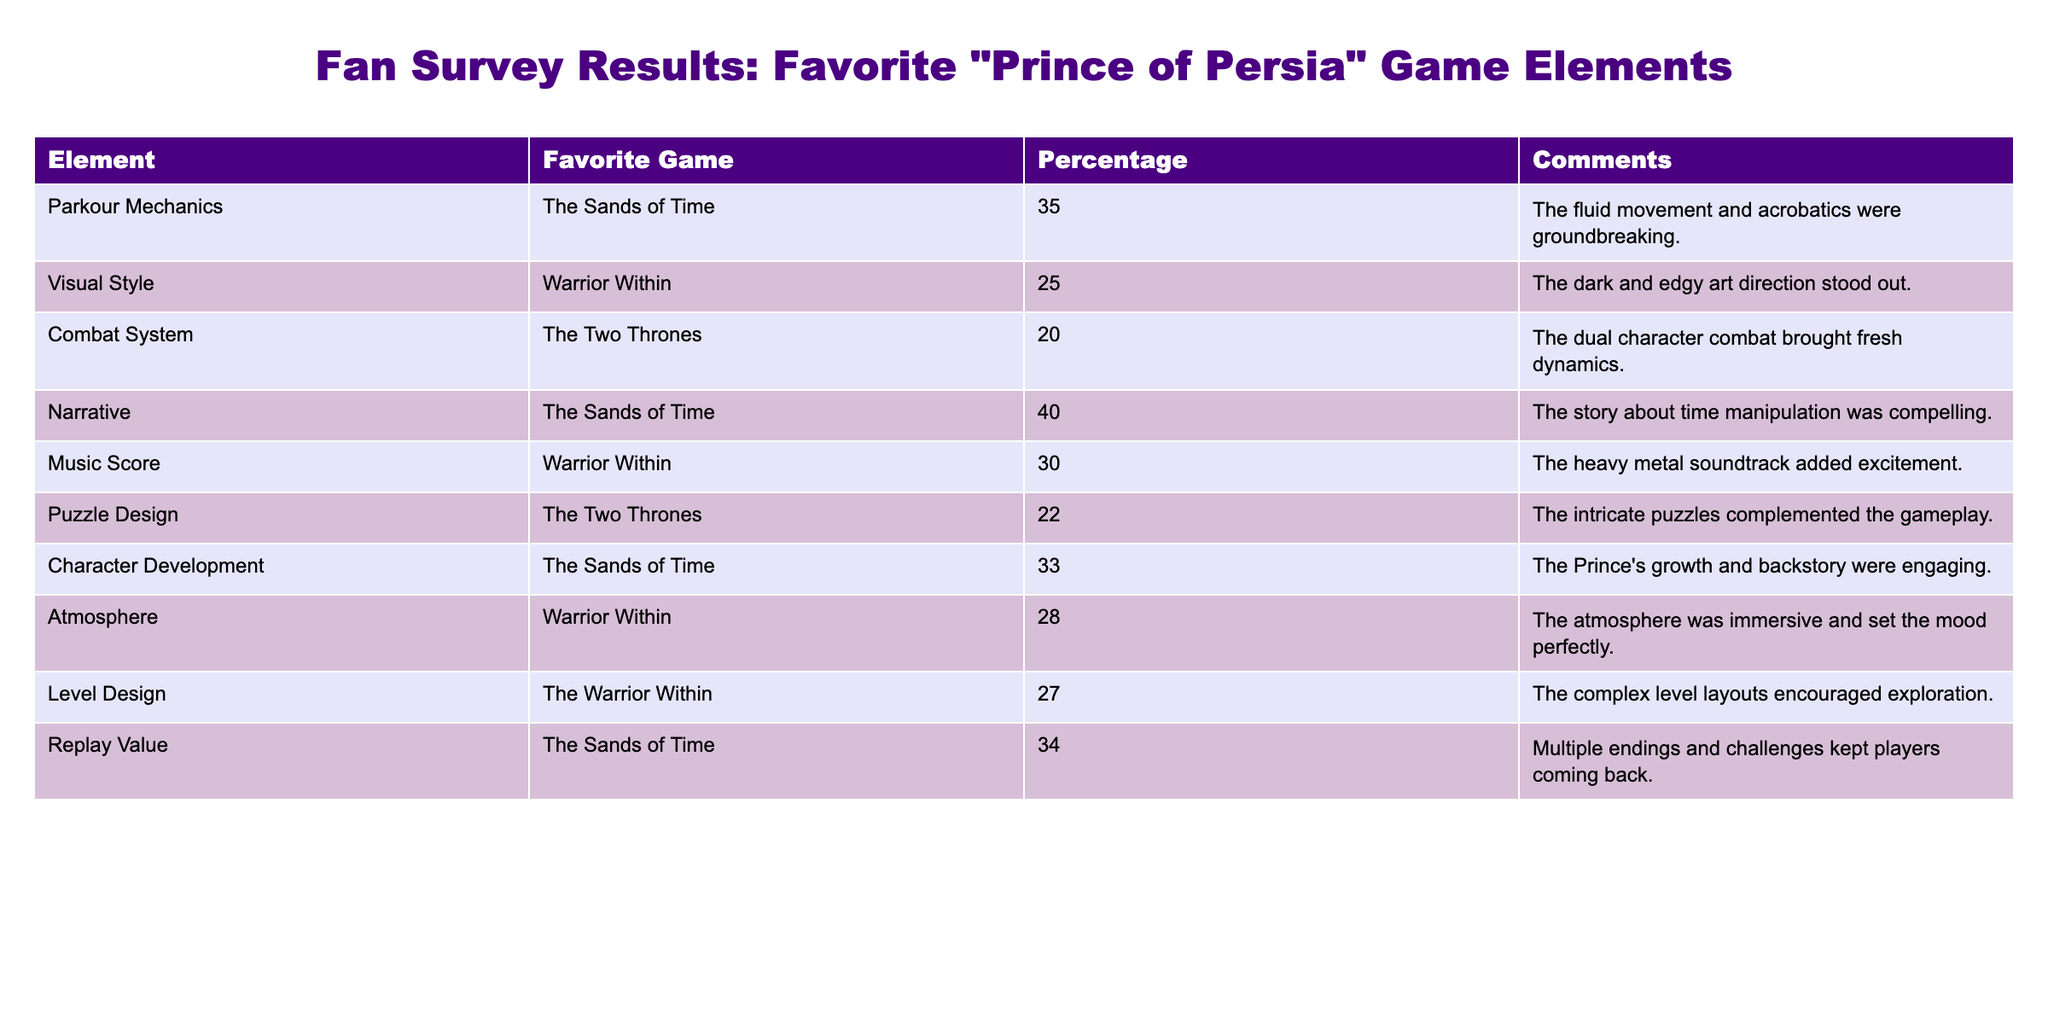What is the percentage of fans who favored the parkour mechanics of "The Sands of Time"? The table shows the favorite game and percentage for each game element. Parkour Mechanics corresponds to "The Sands of Time" with a percentage of 35.
Answer: 35 Which game had the highest percentage for its narrative? The table lists the percentage of fans who favored Narrative for each game. The Sands of Time has the highest percentage of 40 for its narrative.
Answer: 40 What is the sum of the percentages for the "Warrior Within" elements? To find the sum of the percentages for elements related to "Warrior Within," we take the values for Visual Style (25), Music Score (30), Atmosphere (28), and Level Design (27). Adding these gives 25 + 30 + 28 + 27 = 110.
Answer: 110 Is the puzzle design favored more in "The Two Thrones" than in "The Sands of Time"? The table lists the percentages for Puzzle Design. "The Two Thrones" has a percentage of 22, while "The Sands of Time" does not have a puzzle design entry. Thus, comparing 22 to 0 confirms that puzzles are favored more in "The Two Thrones."
Answer: Yes Which game has the lowest percentage for its combat system? The table lists Combat System percentages, with The Two Thrones having a percentage of 20, which is lower than any other game element listed.
Answer: 20 What is the average percentage of fan preference for all elements in "The Sands of Time"? We consider the percentages for all elements related to "The Sands of Time": Parkour Mechanics (35), Narrative (40), Character Development (33), and Replay Value (34). The sum is 35 + 40 + 33 + 34 = 142 and there are four elements, so the average is 142/4 = 35.5.
Answer: 35.5 Does "The Warrior Within" have a higher percentage for Music Score than "The Two Thrones" has for Puzzle Design? The table shows "Warrior Within" has a Music Score percentage of 30, while "The Two Thrones" has Puzzle Design at 22. Since 30 is greater than 22, the answer is yes.
Answer: Yes How many elements from the reviewed games have a percentage of 30 or higher? Checking all percentages, the ones greater than or equal to 30 are Parkour Mechanics (35), Narrative (40), Music Score (30), Character Development (33), Replay Value (34), and Atmosphere (28) is not counted. Counting gives a total of 5 elements.
Answer: 5 What is the difference in percentage between the highest and lowest favorite game elements? The highest percentage is Narrative from The Sands of Time at 40, and the lowest percentage is Combat System from The Two Thrones at 20. The difference is 40 - 20 = 20.
Answer: 20 